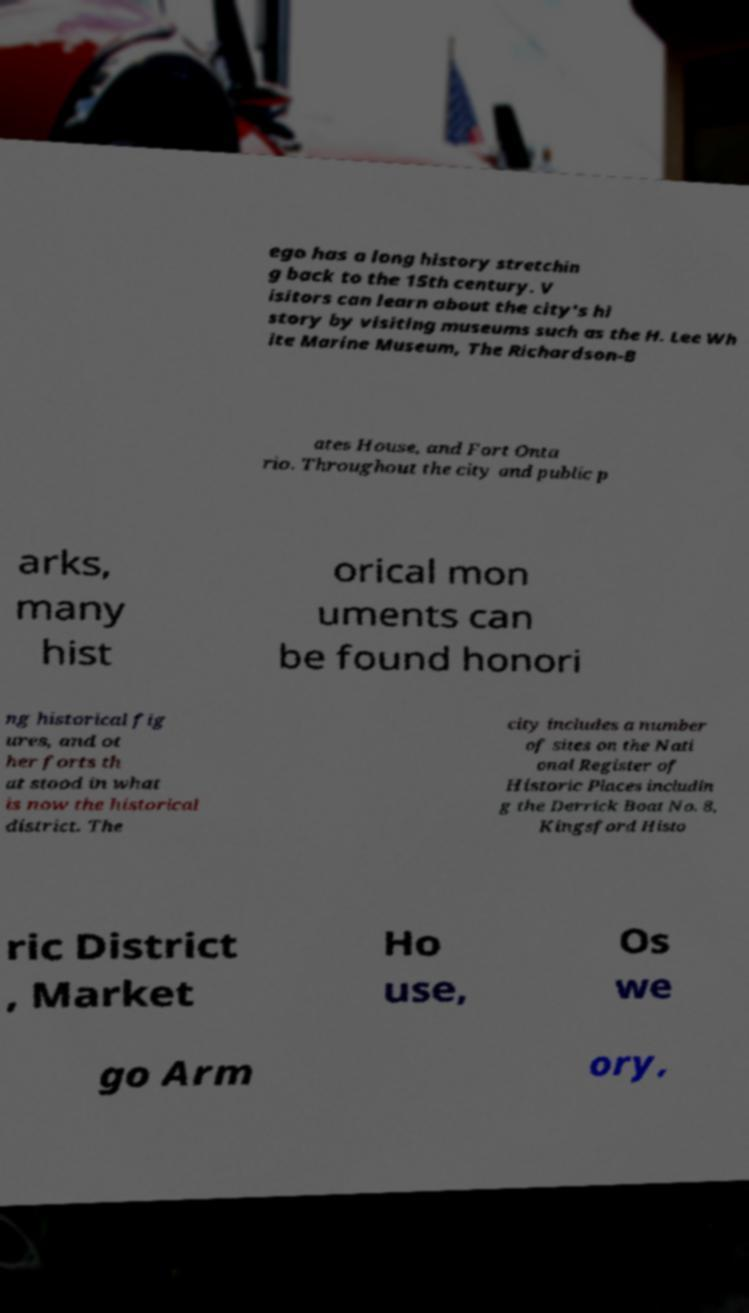What messages or text are displayed in this image? I need them in a readable, typed format. ego has a long history stretchin g back to the 15th century. V isitors can learn about the city's hi story by visiting museums such as the H. Lee Wh ite Marine Museum, The Richardson-B ates House, and Fort Onta rio. Throughout the city and public p arks, many hist orical mon uments can be found honori ng historical fig ures, and ot her forts th at stood in what is now the historical district. The city includes a number of sites on the Nati onal Register of Historic Places includin g the Derrick Boat No. 8, Kingsford Histo ric District , Market Ho use, Os we go Arm ory, 